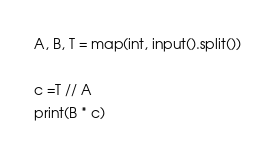<code> <loc_0><loc_0><loc_500><loc_500><_Python_>A, B, T = map(int, input().split())

c =T // A
print(B * c)</code> 